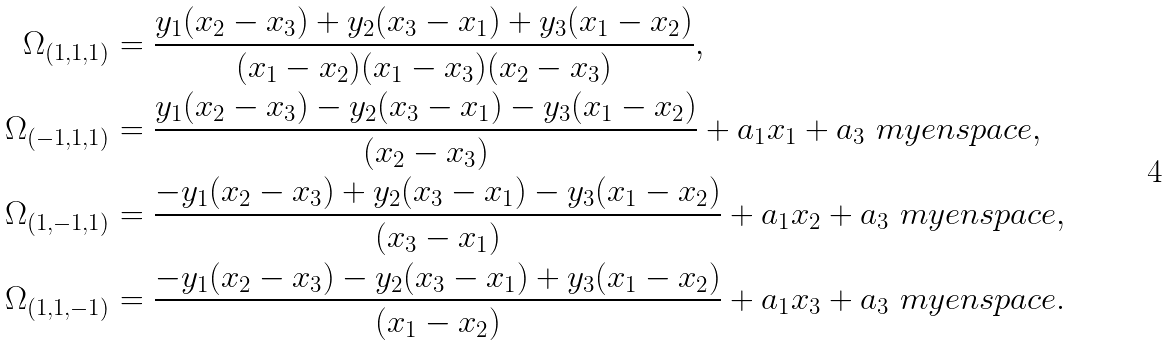Convert formula to latex. <formula><loc_0><loc_0><loc_500><loc_500>\Omega _ { ( 1 , 1 , 1 ) } & = \frac { y _ { 1 } ( x _ { 2 } - x _ { 3 } ) + y _ { 2 } ( x _ { 3 } - x _ { 1 } ) + y _ { 3 } ( x _ { 1 } - x _ { 2 } ) } { ( x _ { 1 } - x _ { 2 } ) ( x _ { 1 } - x _ { 3 } ) ( x _ { 2 } - x _ { 3 } ) } , \\ \Omega _ { ( - 1 , 1 , 1 ) } & = \frac { y _ { 1 } ( x _ { 2 } - x _ { 3 } ) - y _ { 2 } ( x _ { 3 } - x _ { 1 } ) - y _ { 3 } ( x _ { 1 } - x _ { 2 } ) } { ( x _ { 2 } - x _ { 3 } ) } + a _ { 1 } x _ { 1 } + a _ { 3 } \ m y e n s p a c e , \\ \Omega _ { ( 1 , - 1 , 1 ) } & = \frac { - y _ { 1 } ( x _ { 2 } - x _ { 3 } ) + y _ { 2 } ( x _ { 3 } - x _ { 1 } ) - y _ { 3 } ( x _ { 1 } - x _ { 2 } ) } { ( x _ { 3 } - x _ { 1 } ) } + a _ { 1 } x _ { 2 } + a _ { 3 } \ m y e n s p a c e , \\ \Omega _ { ( 1 , 1 , - 1 ) } & = \frac { - y _ { 1 } ( x _ { 2 } - x _ { 3 } ) - y _ { 2 } ( x _ { 3 } - x _ { 1 } ) + y _ { 3 } ( x _ { 1 } - x _ { 2 } ) } { ( x _ { 1 } - x _ { 2 } ) } + a _ { 1 } x _ { 3 } + a _ { 3 } \ m y e n s p a c e .</formula> 